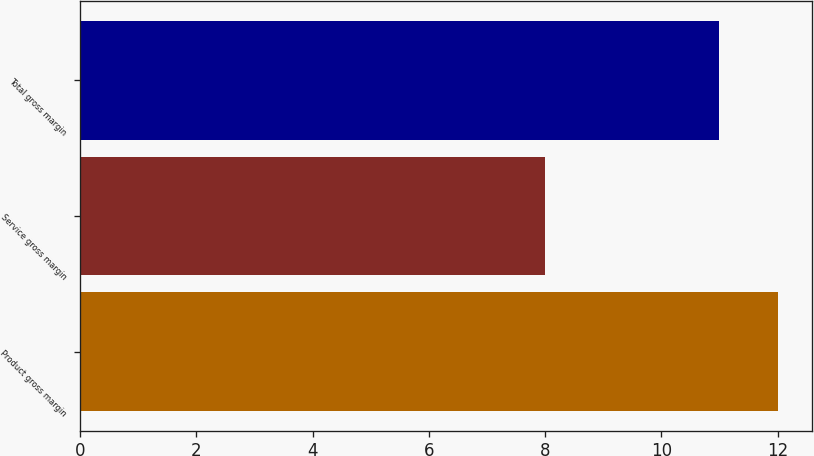Convert chart to OTSL. <chart><loc_0><loc_0><loc_500><loc_500><bar_chart><fcel>Product gross margin<fcel>Service gross margin<fcel>Total gross margin<nl><fcel>12<fcel>8<fcel>11<nl></chart> 